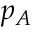<formula> <loc_0><loc_0><loc_500><loc_500>p _ { A }</formula> 